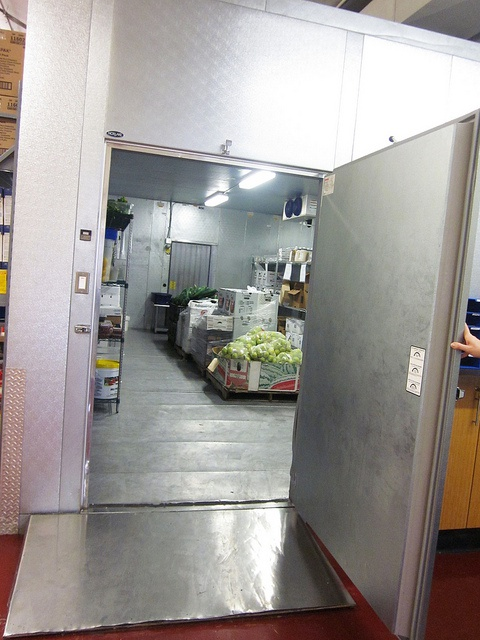Describe the objects in this image and their specific colors. I can see people in gray, tan, and brown tones, apple in gray, olive, darkgreen, and beige tones, apple in gray, olive, khaki, beige, and tan tones, apple in gray, olive, and khaki tones, and apple in gray, olive, khaki, and beige tones in this image. 